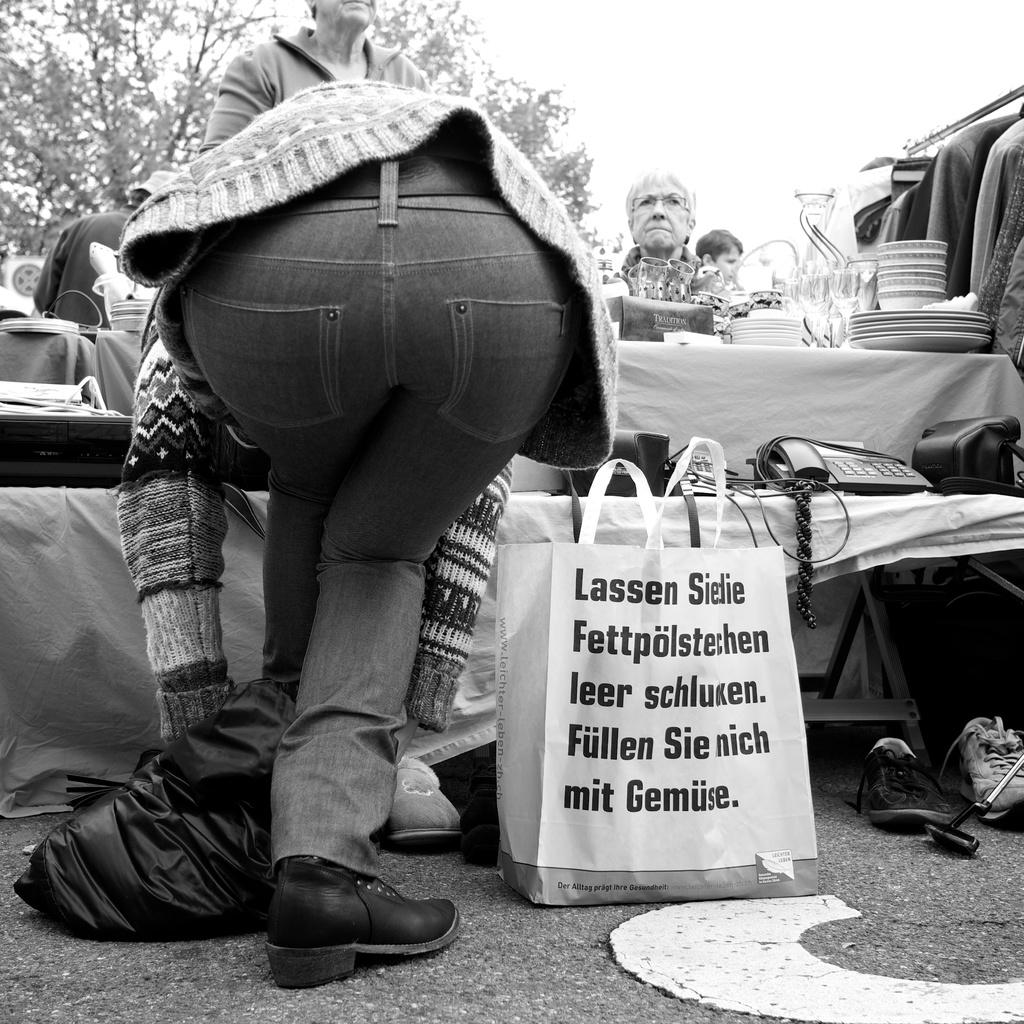<image>
Give a short and clear explanation of the subsequent image. Person standing in front of a bag which starts with the word "Lassen". 